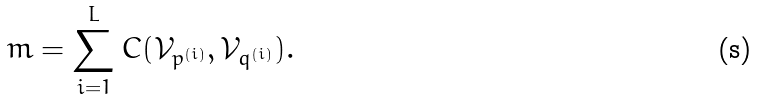<formula> <loc_0><loc_0><loc_500><loc_500>m = \sum _ { i = 1 } ^ { L } C ( \mathcal { V } _ { p ^ { ( i ) } } , \mathcal { V } _ { q ^ { ( i ) } } ) .</formula> 